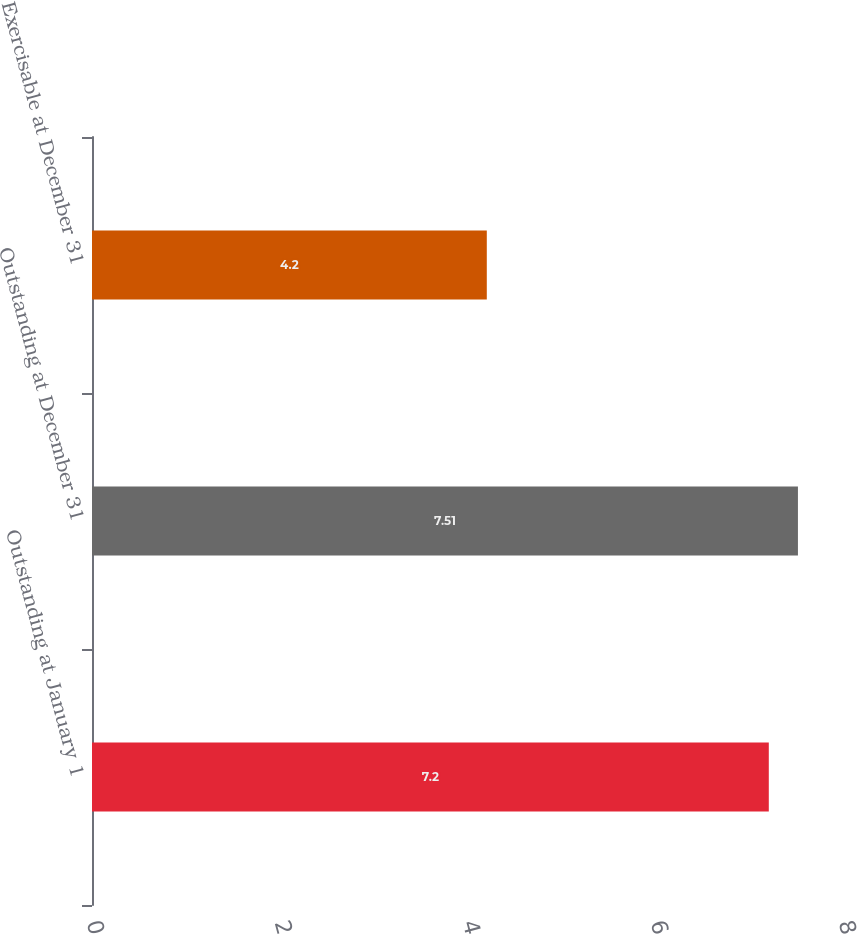Convert chart. <chart><loc_0><loc_0><loc_500><loc_500><bar_chart><fcel>Outstanding at January 1<fcel>Outstanding at December 31<fcel>Exercisable at December 31<nl><fcel>7.2<fcel>7.51<fcel>4.2<nl></chart> 